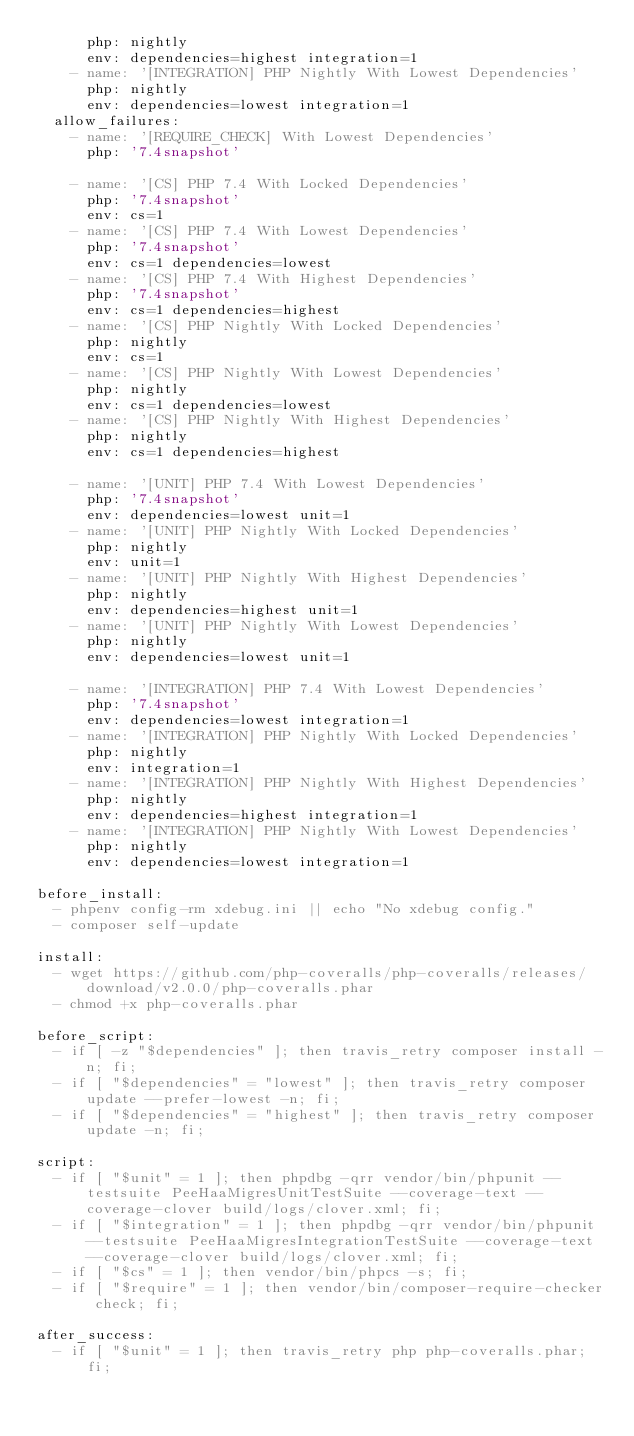<code> <loc_0><loc_0><loc_500><loc_500><_YAML_>      php: nightly
      env: dependencies=highest integration=1
    - name: '[INTEGRATION] PHP Nightly With Lowest Dependencies'
      php: nightly
      env: dependencies=lowest integration=1
  allow_failures:
    - name: '[REQUIRE_CHECK] With Lowest Dependencies'
      php: '7.4snapshot'

    - name: '[CS] PHP 7.4 With Locked Dependencies'
      php: '7.4snapshot'
      env: cs=1
    - name: '[CS] PHP 7.4 With Lowest Dependencies'
      php: '7.4snapshot'
      env: cs=1 dependencies=lowest
    - name: '[CS] PHP 7.4 With Highest Dependencies'
      php: '7.4snapshot'
      env: cs=1 dependencies=highest
    - name: '[CS] PHP Nightly With Locked Dependencies'
      php: nightly
      env: cs=1
    - name: '[CS] PHP Nightly With Lowest Dependencies'
      php: nightly
      env: cs=1 dependencies=lowest
    - name: '[CS] PHP Nightly With Highest Dependencies'
      php: nightly
      env: cs=1 dependencies=highest

    - name: '[UNIT] PHP 7.4 With Lowest Dependencies'
      php: '7.4snapshot'
      env: dependencies=lowest unit=1
    - name: '[UNIT] PHP Nightly With Locked Dependencies'
      php: nightly
      env: unit=1
    - name: '[UNIT] PHP Nightly With Highest Dependencies'
      php: nightly
      env: dependencies=highest unit=1
    - name: '[UNIT] PHP Nightly With Lowest Dependencies'
      php: nightly
      env: dependencies=lowest unit=1

    - name: '[INTEGRATION] PHP 7.4 With Lowest Dependencies'
      php: '7.4snapshot'
      env: dependencies=lowest integration=1
    - name: '[INTEGRATION] PHP Nightly With Locked Dependencies'
      php: nightly
      env: integration=1
    - name: '[INTEGRATION] PHP Nightly With Highest Dependencies'
      php: nightly
      env: dependencies=highest integration=1
    - name: '[INTEGRATION] PHP Nightly With Lowest Dependencies'
      php: nightly
      env: dependencies=lowest integration=1

before_install:
  - phpenv config-rm xdebug.ini || echo "No xdebug config."
  - composer self-update

install:
  - wget https://github.com/php-coveralls/php-coveralls/releases/download/v2.0.0/php-coveralls.phar
  - chmod +x php-coveralls.phar

before_script:
  - if [ -z "$dependencies" ]; then travis_retry composer install -n; fi;
  - if [ "$dependencies" = "lowest" ]; then travis_retry composer update --prefer-lowest -n; fi;
  - if [ "$dependencies" = "highest" ]; then travis_retry composer update -n; fi;

script:
  - if [ "$unit" = 1 ]; then phpdbg -qrr vendor/bin/phpunit --testsuite PeeHaaMigresUnitTestSuite --coverage-text --coverage-clover build/logs/clover.xml; fi;
  - if [ "$integration" = 1 ]; then phpdbg -qrr vendor/bin/phpunit --testsuite PeeHaaMigresIntegrationTestSuite --coverage-text --coverage-clover build/logs/clover.xml; fi;
  - if [ "$cs" = 1 ]; then vendor/bin/phpcs -s; fi;
  - if [ "$require" = 1 ]; then vendor/bin/composer-require-checker check; fi;

after_success:
  - if [ "$unit" = 1 ]; then travis_retry php php-coveralls.phar; fi;
</code> 